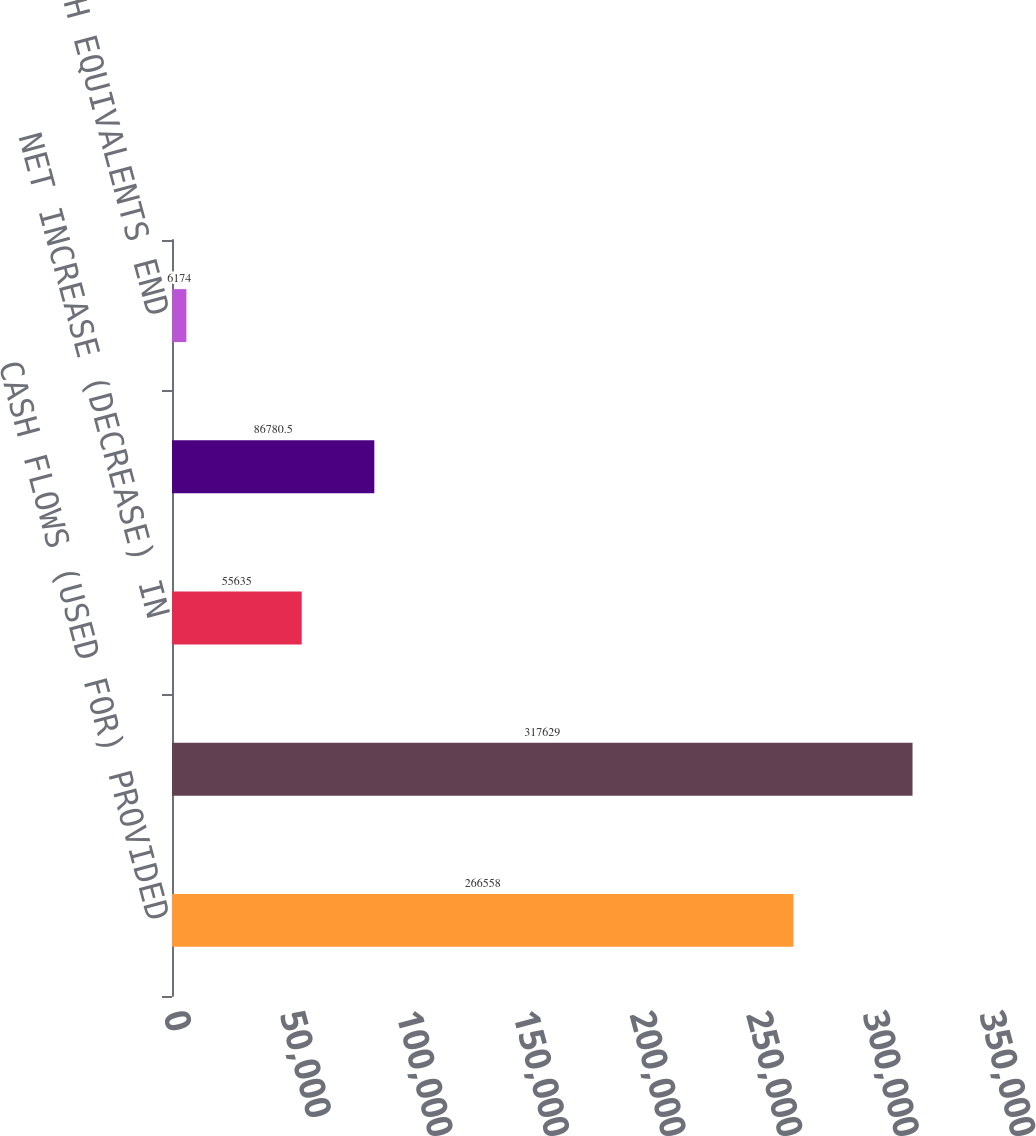Convert chart to OTSL. <chart><loc_0><loc_0><loc_500><loc_500><bar_chart><fcel>CASH FLOWS (USED FOR) PROVIDED<fcel>Cash provided by (used for)<fcel>NET INCREASE (DECREASE) IN<fcel>CASH AND CASH EQUIVALENTS<fcel>CASH AND CASH EQUIVALENTS END<nl><fcel>266558<fcel>317629<fcel>55635<fcel>86780.5<fcel>6174<nl></chart> 